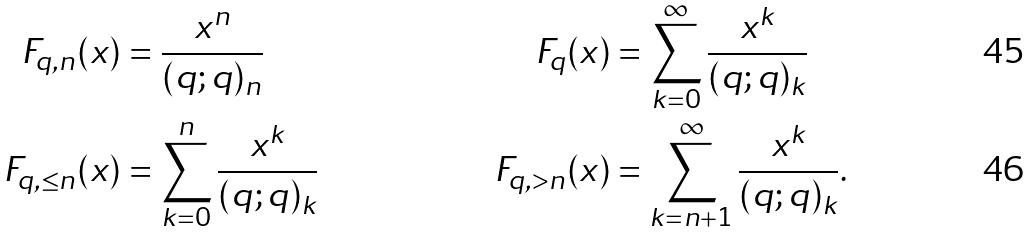Convert formula to latex. <formula><loc_0><loc_0><loc_500><loc_500>F _ { q , n } ( x ) & = \frac { x ^ { n } } { ( q ; q ) _ { n } } & F _ { q } ( x ) & = \sum _ { k = 0 } ^ { \infty } \frac { x ^ { k } } { ( q ; q ) _ { k } } \\ F _ { q , \leq n } ( x ) & = \sum _ { k = 0 } ^ { n } \frac { x ^ { k } } { ( q ; q ) _ { k } } & F _ { q , > n } ( x ) & = \sum _ { k = { n + 1 } } ^ { \infty } \frac { x ^ { k } } { ( q ; q ) _ { k } } .</formula> 